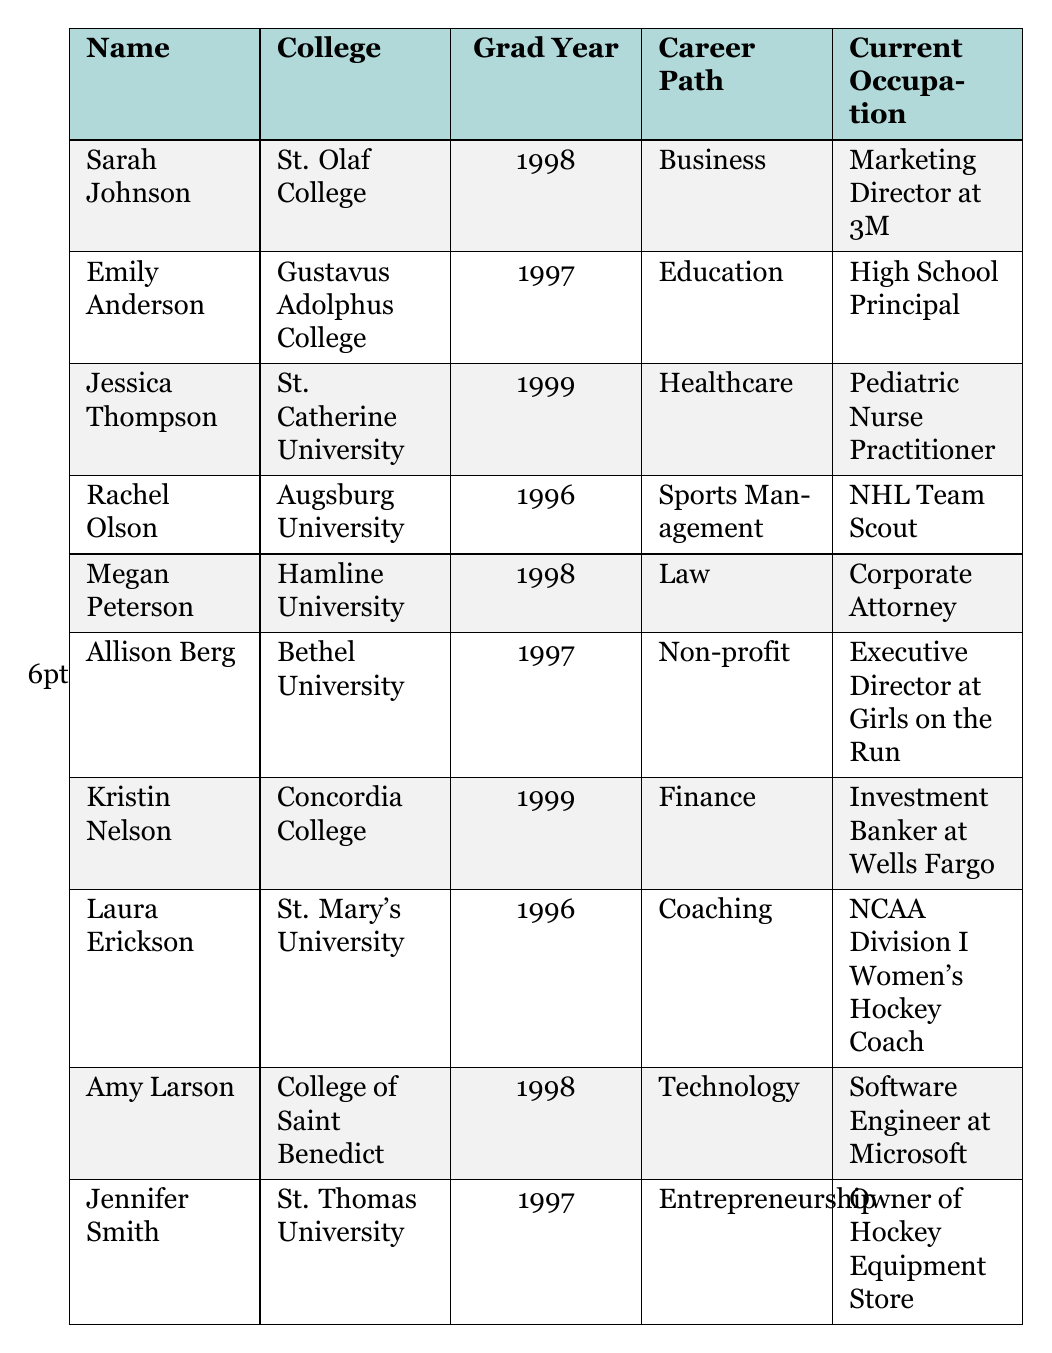What career path did Sarah Johnson pursue after graduation? Sarah Johnson's career path listed in the table is Business, and her current occupation is Marketing Director at 3M.
Answer: Business Which player is working in Healthcare? The player working in Healthcare is Jessica Thompson, who is a Pediatric Nurse Practitioner.
Answer: Jessica Thompson How many players graduated in 1996? In the table, there are two players who graduated in 1996: Rachel Olson and Laura Erickson.
Answer: 2 What is the current occupation of the player who graduated in 1997 from St. Thomas University? Emily Anderson graduated from Gustavus Adolphus College, not St. Thomas University. Jennifer Smith graduated from St. Thomas University and her current occupation is the owner of a Hockey Equipment Store.
Answer: Owner of Hockey Equipment Store Which college had the most diverse career paths according to this data? By reviewing the data, we can assess that the colleges have varied career paths. However, if we consider the players' occupations: St. Olaf College (Business), Gustavus Adolphus College (Education), and St. Catherine University (Healthcare). The college with the most varied career paths would be Augsburg University with NHL Team Scout in Sports Management, indicating a connection to sports.
Answer: Augsburg University Is there any player who is a Corporate Attorney? Yes, there is a player, Megan Peterson, who is a Corporate Attorney.
Answer: Yes Which player from the 1998 graduating class is working in Technology? From the 1998 graduating class, Amy Larson is the player working in Technology, specifically as a Software Engineer at Microsoft.
Answer: Amy Larson Are there any players involved in non-profit work? Yes, Allison Berg is involved in non-profit work, serving as the Executive Director at Girls on the Run.
Answer: Yes List the players who graduated in 1999 and their career paths. The players who graduated in 1999 are Jessica Thompson (Healthcare) and Kristin Nelson (Finance).
Answer: Jessica Thompson and Kristin Nelson How many players are working in the field of Education? Based on the table, there is one player working in Education, Emily Anderson, who is a High School Principal.
Answer: 1 Which occupation is represented by more than one player? None of the listed occupations are represented by more than one player; each player's occupation is unique according to the table data.
Answer: None 